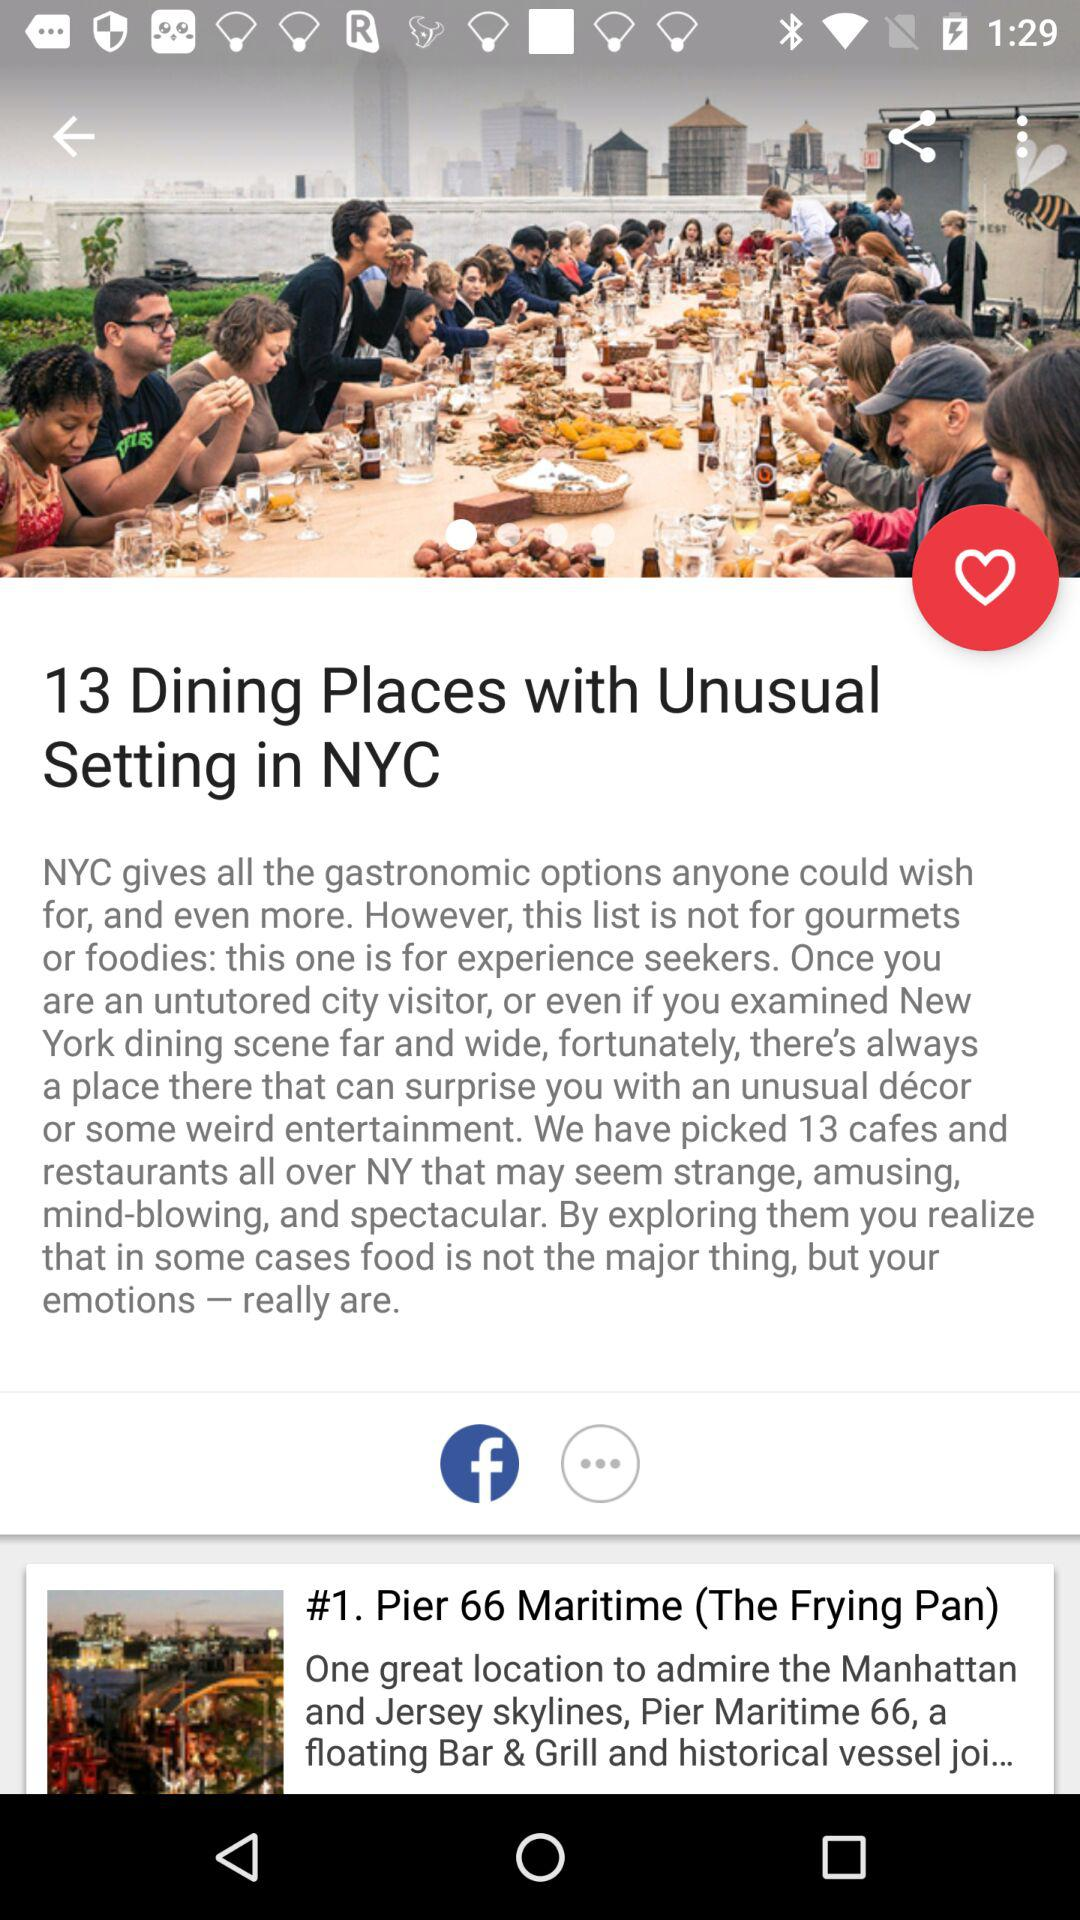What is another name for "Pier 66 Maritime"? The another name for "Pier 66 Maritime" is "The Frying Pan". 